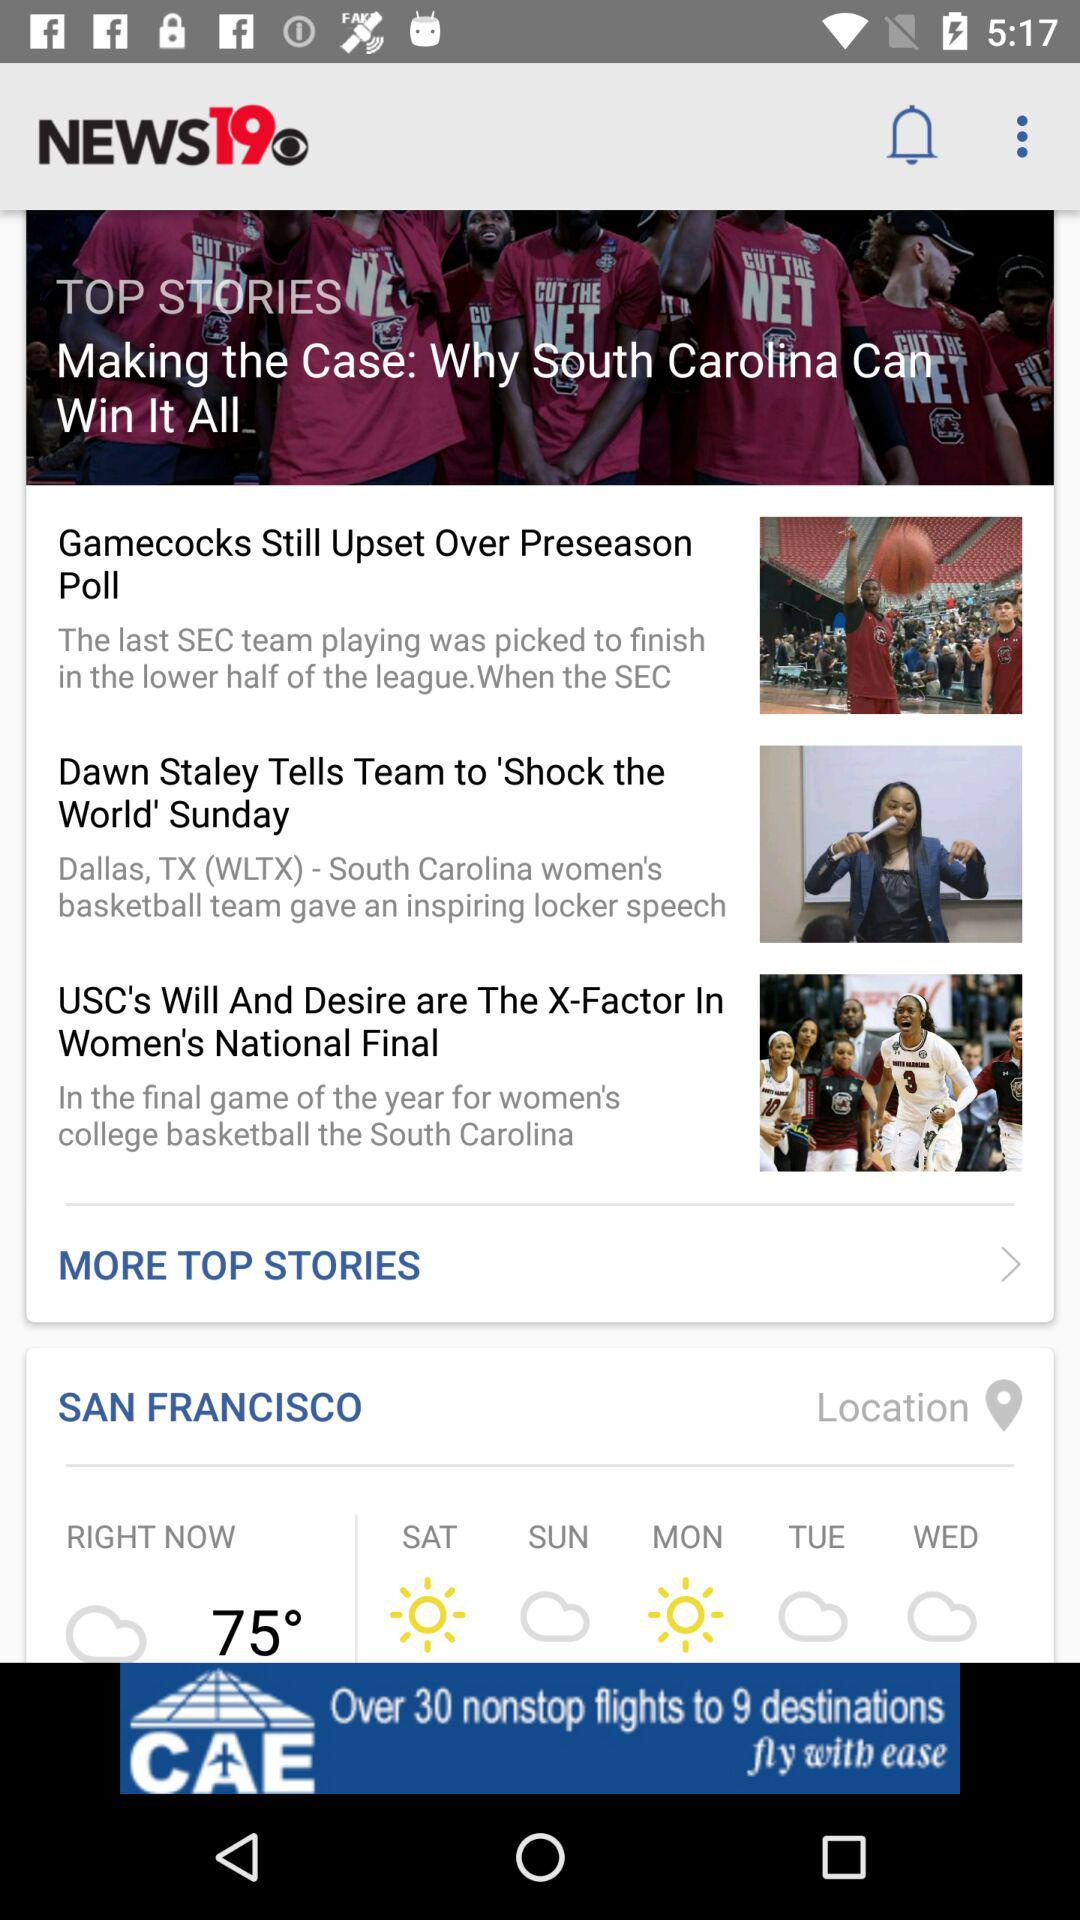What is the application name? The application name is "NEWS19". 